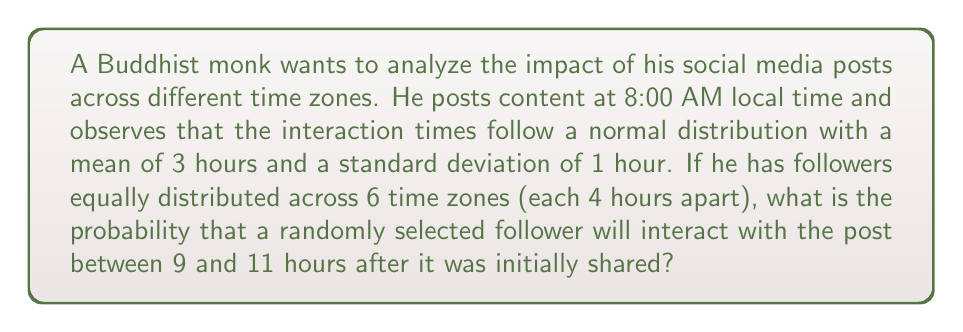What is the answer to this math problem? Let's approach this step-by-step:

1) First, we need to understand that the interaction time for each time zone follows a normal distribution:
   $X_i \sim N(\mu_i, \sigma^2)$, where $\sigma = 1$ hour for all zones.

2) The means for each time zone will be:
   $\mu_1 = 3, \mu_2 = 7, \mu_3 = 11, \mu_4 = 15, \mu_5 = 19, \mu_6 = 23$ hours

3) We want to find $P(9 < X < 11)$ for a randomly selected follower.

4) This probability is the average of the probabilities for each time zone:

   $P(9 < X < 11) = \frac{1}{6}\sum_{i=1}^{6} P(9 < X_i < 11)$

5) For each time zone, we need to calculate:

   $P(9 < X_i < 11) = \Phi(\frac{11-\mu_i}{\sigma}) - \Phi(\frac{9-\mu_i}{\sigma})$

   Where $\Phi$ is the standard normal cumulative distribution function.

6) Let's calculate for each zone:

   Zone 1: $\Phi(8) - \Phi(6) \approx 0$
   Zone 2: $\Phi(4) - \Phi(2) \approx 0.4772$
   Zone 3: $\Phi(0) - \Phi(-2) \approx 0.4772$
   Zone 4: $\Phi(-4) - \Phi(-6) \approx 0$
   Zone 5: $\Phi(-8) - \Phi(-10) \approx 0$
   Zone 6: $\Phi(-12) - \Phi(-14) \approx 0$

7) Now we can sum these probabilities and divide by 6:

   $P(9 < X < 11) = \frac{1}{6}(0 + 0.4772 + 0.4772 + 0 + 0 + 0) \approx 0.1590$

Therefore, the probability is approximately 0.1590 or 15.90%.
Answer: 0.1590 